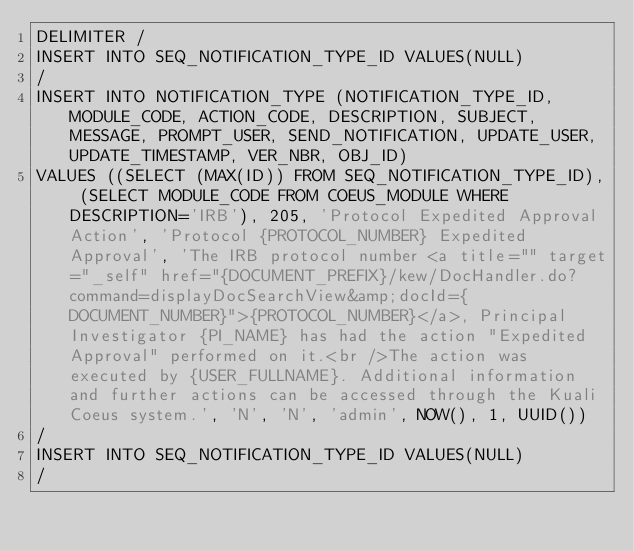<code> <loc_0><loc_0><loc_500><loc_500><_SQL_>DELIMITER /
INSERT INTO SEQ_NOTIFICATION_TYPE_ID VALUES(NULL)
/
INSERT INTO NOTIFICATION_TYPE (NOTIFICATION_TYPE_ID, MODULE_CODE, ACTION_CODE, DESCRIPTION, SUBJECT, MESSAGE, PROMPT_USER, SEND_NOTIFICATION, UPDATE_USER, UPDATE_TIMESTAMP, VER_NBR, OBJ_ID)
VALUES ((SELECT (MAX(ID)) FROM SEQ_NOTIFICATION_TYPE_ID), (SELECT MODULE_CODE FROM COEUS_MODULE WHERE DESCRIPTION='IRB'), 205, 'Protocol Expedited Approval Action', 'Protocol {PROTOCOL_NUMBER} Expedited Approval', 'The IRB protocol number <a title="" target="_self" href="{DOCUMENT_PREFIX}/kew/DocHandler.do?command=displayDocSearchView&amp;docId={DOCUMENT_NUMBER}">{PROTOCOL_NUMBER}</a>, Principal Investigator {PI_NAME} has had the action "Expedited Approval" performed on it.<br />The action was executed by {USER_FULLNAME}. Additional information and further actions can be accessed through the Kuali Coeus system.', 'N', 'N', 'admin', NOW(), 1, UUID())
/
INSERT INTO SEQ_NOTIFICATION_TYPE_ID VALUES(NULL)
/</code> 